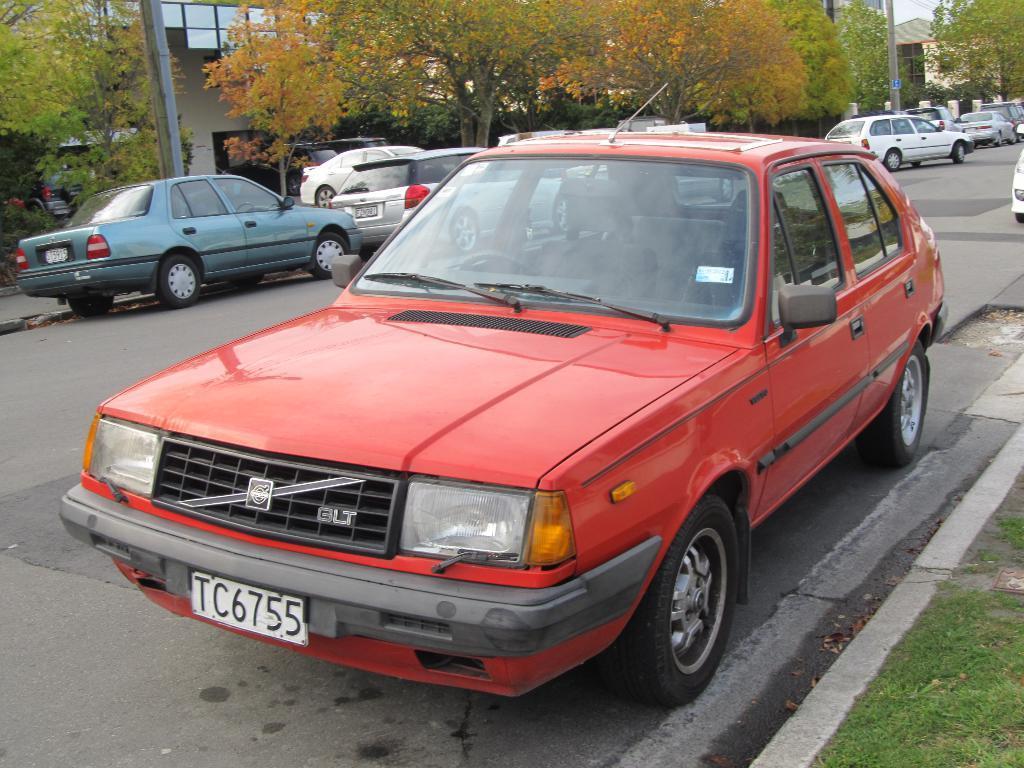Describe this image in one or two sentences. In this picture we can see vehicles on the road, grass, trees, poles and in the background we can see buildings. 